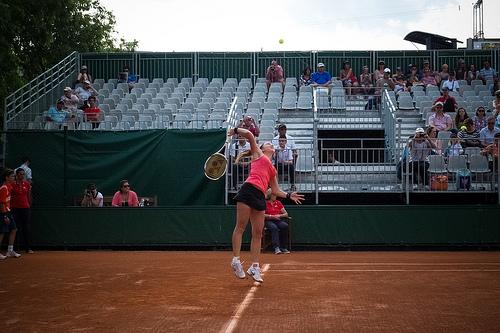What is the color of the wall behind the players? The color of the wall is green. Mention two noticeable details about the woman who is playing tennis. The woman is wearing a pink top, black skirt, and a black arm band. How would you describe the court and the seating arrangement around it? The court is made of clay with white lines and surrounded by green walls with several rows of mostly empty white seats where spectators watch the match. Describe the lighting and overall quality of the image. The lighting is even, and the image has clear details, making the overall quality quite good. Are there any peculiar details about the tennis racket being used? There are no peculiar details, it's a large tennis racket in the player's hand. Count the number of people watching the match that can be seen in the image. There are approximately 15 people watching the tennis match. Is the sky blue or cloudy in the image? The sky in the image is blue and clear. What is the general sentiment of the spectators in the stands? Some people are watching the match with disinterest, while others are engaged. Provide a brief description of the scene displayed in the image. A woman in a mid-jump playing tennis on a clay court, with spectators seated on the stands watching the match, and a large tree overlooking the field. What type of footwear is the tennis player wearing?  The tennis player is wearing white tennis shoes. Describe the court in the image. The court is a clay or brown colored court with white lines. What are the spectators doing during the tennis game? Watching with varying levels of interest What is the common color of the empty chairs in the stands? White What are the people doing by the green partition? Seated Are there several people playing tennis on the court? There's only one tennis player mentioned throughout the given captions (the woman playing tennis); thus, this question wrongly suggests that there are multiple people playing. What kind of surface is the tennis court made of? Clay What color is the material of the partition surrounding two people? Green Is the sky filled with clouds? The given captions describe the sky as "blue and clear," so this question wrongly attributes the sky with cloud cover. How many spectators are on the field? Two What is one accessory the tennis player is wearing? A black arm band Identify the dominant color of the sky. Blue and clear Is the tennis court made of grass? The court is described as either "clay" or "brown," so this question wrongly attributes the court to be made of grass. Is the tennis player wearing a yellow shirt? The tennis player is not wearing a yellow shirt; the woman is wearing a pink top, thus this question provides a wrong attribute for her clothing. Is the tennis ball on the ground? In the given captions, the tennis ball is described as "sails through the air," implying that it's mid-flight; thus, this question incorrectly attributes the ball's location as being on the ground. Make a creative statement about what's happening in the image. In a charged tennis match, a woman leaps skyward on a sun-bathed clay court as spectators display varying levels of curiosity. Describe the woman's outfit on the court. The woman is wearing a pink top, black skirt, and an arm band. Are the spectators sitting on green seats? The seats in the stands are described as "empty white chairs" and "empty white seats," so this question wrongly attributes the color of the seats as green. Do you see any large plants near the field? Yes, a large tree overlooks the field. What is happening involving the tennis racket? It is in the player's hand and the woman is swinging it. What important event is happening in the image? A woman is playing tennis and the tennis player is jumping up. Identify the color of the shirt of a person wearing a red shirt. Red Describe the footwear of the tennis player. A pair of white sneakers What type of ball is sailing through the air? A tennis ball 